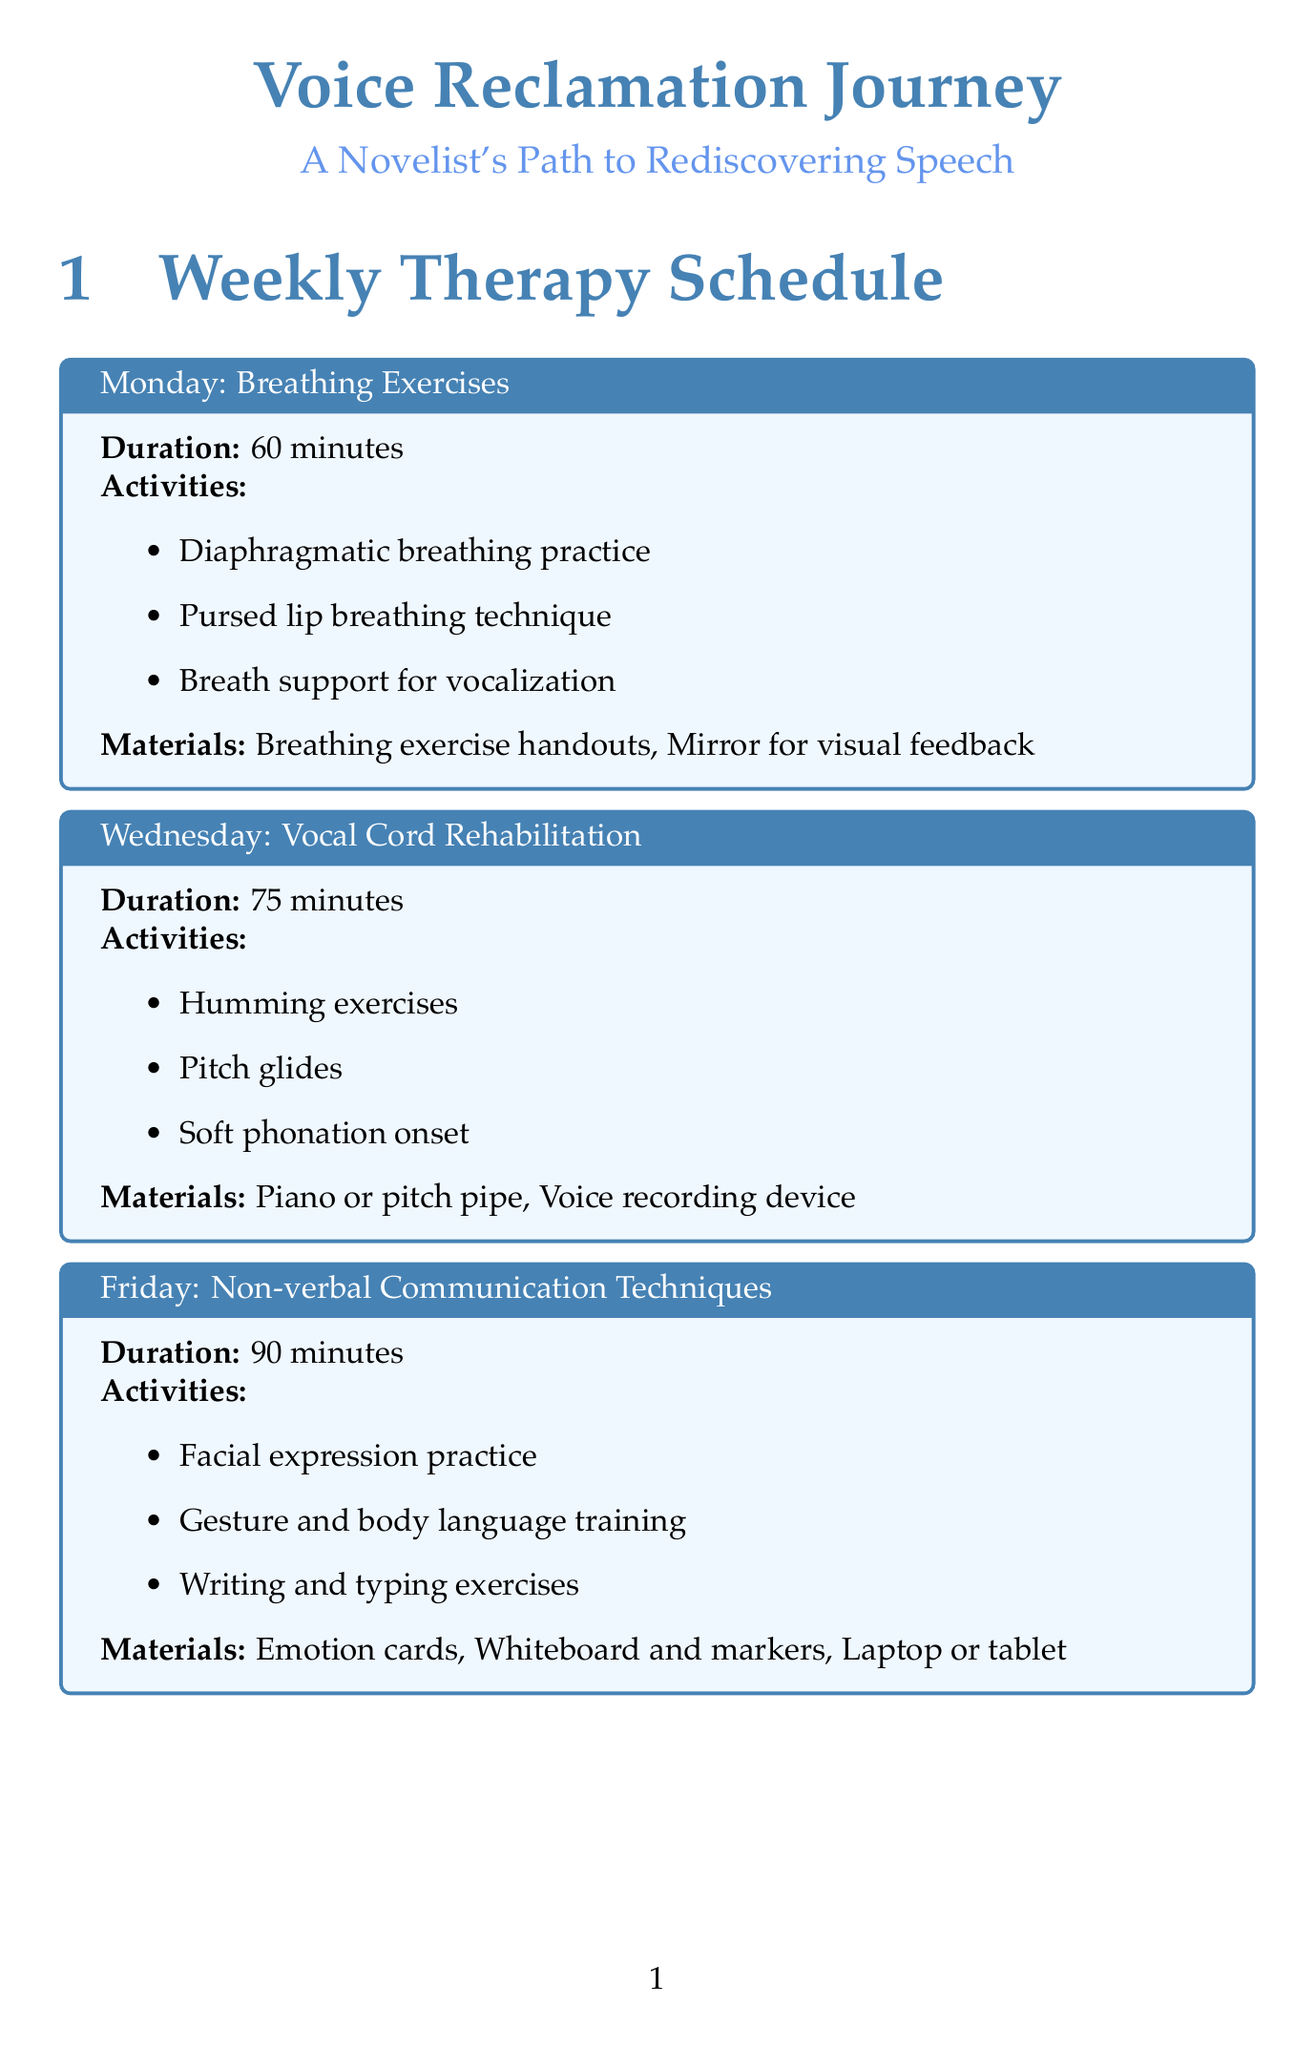What is the duration of the Monday session? The duration is mentioned in the document for each session type, specifically for Monday it states 60 minutes.
Answer: 60 minutes What is the focus of the Wednesday session? The focus is explicitly listed for each session day in the document; for Wednesday, it is Vocal Cord Rehabilitation.
Answer: Vocal Cord Rehabilitation How many activities are planned for the Friday session? The number of activities is counted directly from the list provided for Friday's session, which includes three activities.
Answer: 3 What is the name of the support group? The document clearly specifies the support group name under the support group section as "Voices Reclaimed: Writers' Support Circle".
Answer: Voices Reclaimed: Writers' Support Circle How often is progress tracked? The frequency of progress tracking is stated in the document, which indicates that it is bi-weekly.
Answer: Bi-weekly What type of app is suggested for the at-home exercise? The at-home exercise description mentions the use of a text-to-speech app specifically for storytelling practice.
Answer: text-to-speech app What is included in the materials needed for the Friday session? The materials are listed under the Friday session details, which state that Emotion cards, Whiteboard and markers, and Laptop or tablet are needed.
Answer: Emotion cards, Whiteboard and markers, Laptop or tablet What method is used for progress tracking? The document mentions the method as CAPE-V (Consensus Auditory-Perceptual Evaluation of Voice) explicitly listed under the progress tracking section.
Answer: CAPE-V 